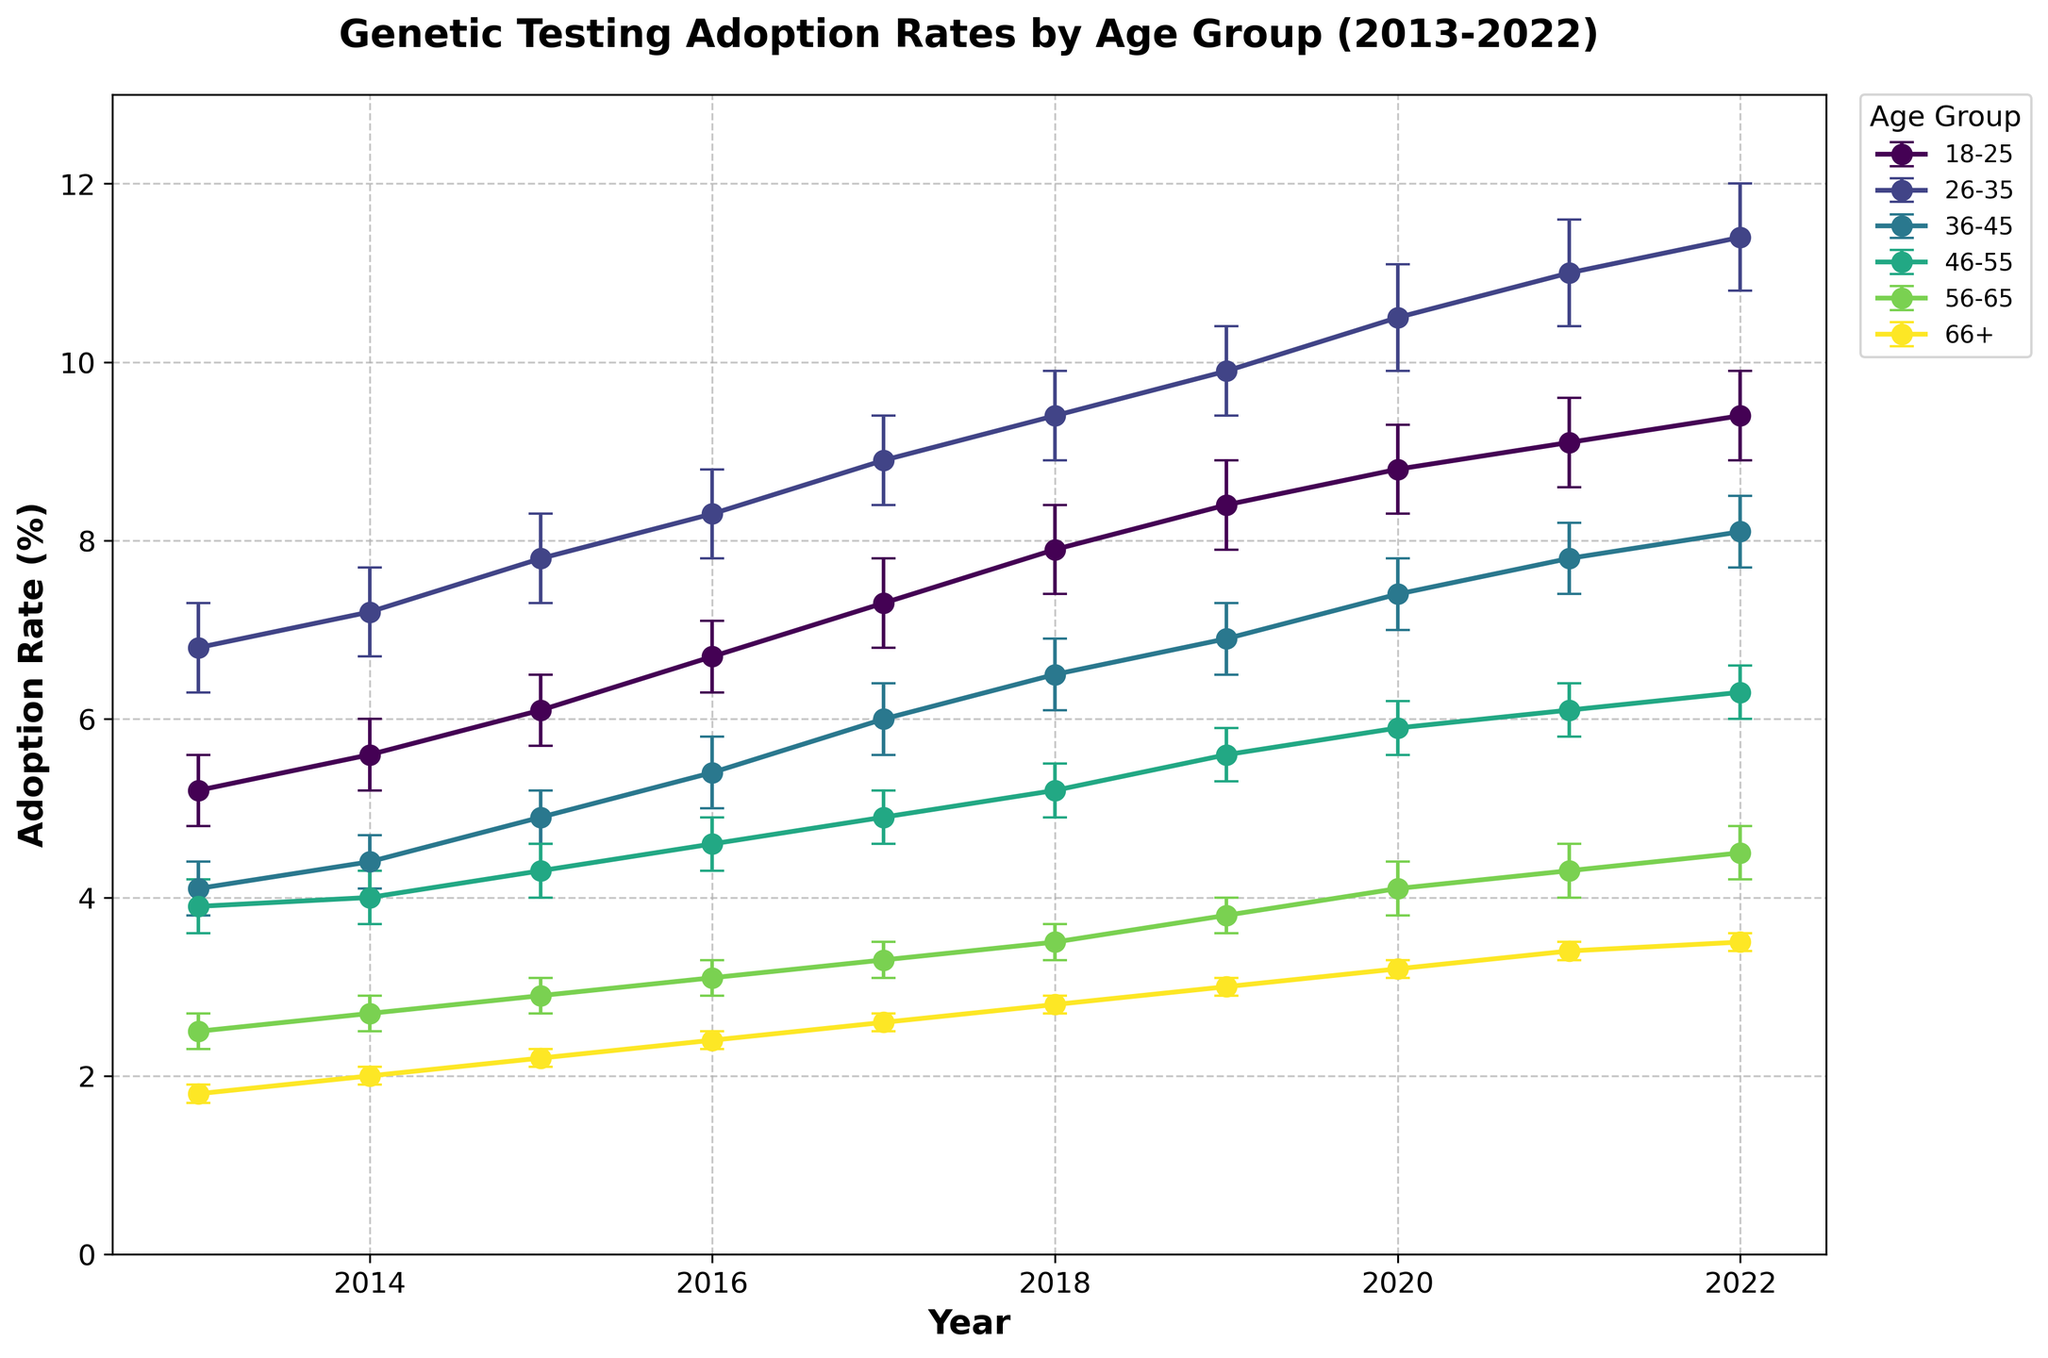What is the title of the figure? The title of the figure is displayed prominently at the top. It states "Genetic Testing Adoption Rates by Age Group (2013-2022)".
Answer: Genetic Testing Adoption Rates by Age Group (2013-2022) Which age group consistently shows the highest adoption rate over the years? By looking at the lines representing each age group, the line for the age group "26-35" is consistently the highest across the plotted years.
Answer: 26-35 How did the adoption rate for the age group 18-25 change from 2013 to 2022? Find the data points of 18-25 group in 2013 and 2022. In 2013 the rate was 5.2%, and it increased to 9.4% in 2022. Subtract the initial rate from the final rate to determine the change: 9.4% - 5.2% = 4.2%.
Answer: Increased by 4.2% Which age group had the lowest adoption rate in 2015? Locate the data points for the year 2015 and compare the adoption rates for each age group. The age group "66+" had the lowest rate at 2.2%.
Answer: 66+ What was the average adoption rate for the age group 36-45 over the last decade? Extract the annual adoption rates for the age group 36-45 from 2013 to 2022 and calculate their average: (4.1 + 4.4 + 4.9 + 5.4 + 6.0 + 6.5 + 6.9 + 7.4 + 7.8 + 8.1) / 10. The sum is 61.5, so the average is 61.5 / 10 = 6.15.
Answer: 6.15 In which year did the age group 46-55 surpass an adoption rate of 5%, and did it stay above this threshold afterward? Examine the line for the age group 46-55. In 2018, the adoption rate is 5.2%, and it remains above 5% in subsequent years (5.6% in 2019, 5.9% in 2020, 6.1% in 2021, and 6.3% in 2022).
Answer: 2018 and yes Which age group had the steepest increase in adoption rates from 2013 to 2022? Find the difference in adoption rates between 2013 and 2022 for all age groups. The 26-35 age group increased from 6.8% to 11.4%, a difference of 4.6%, which is the steepest increase among all groups.
Answer: 26-35 How does the error bar size of the age group 56-65 in 2022 compare to that in 2013? Look at the error bars for the 56-65 age group in 2013 and 2022. In both years, the error is identical at 0.2%.
Answer: Same (0.2%) What was the adoption rate trend for the age group 26-35 between 2016 and 2020? Look at the points for the 26-35 age group from 2016 to 2020. The adoption rate goes from 8.3% (2016), 8.9% (2017), 9.4% (2018), 9.9% (2019), to 10.5% (2020). The trend shows a continuous increase.
Answer: Increasing In which years did the age group 66+ have an adoption rate greater than 2% but less than 3%? Find the data points for the age group 66+ from 2013 to 2022. 2015 (2.2%), 2016 (2.4%), 2017 (2.6%), 2018 (2.8%), 2019 (3.0%), and 2020-2022 (>3%). Therefore, the years are 2015, 2016, 2017, and 2018.
Answer: 2015, 2016, 2017, 2018 